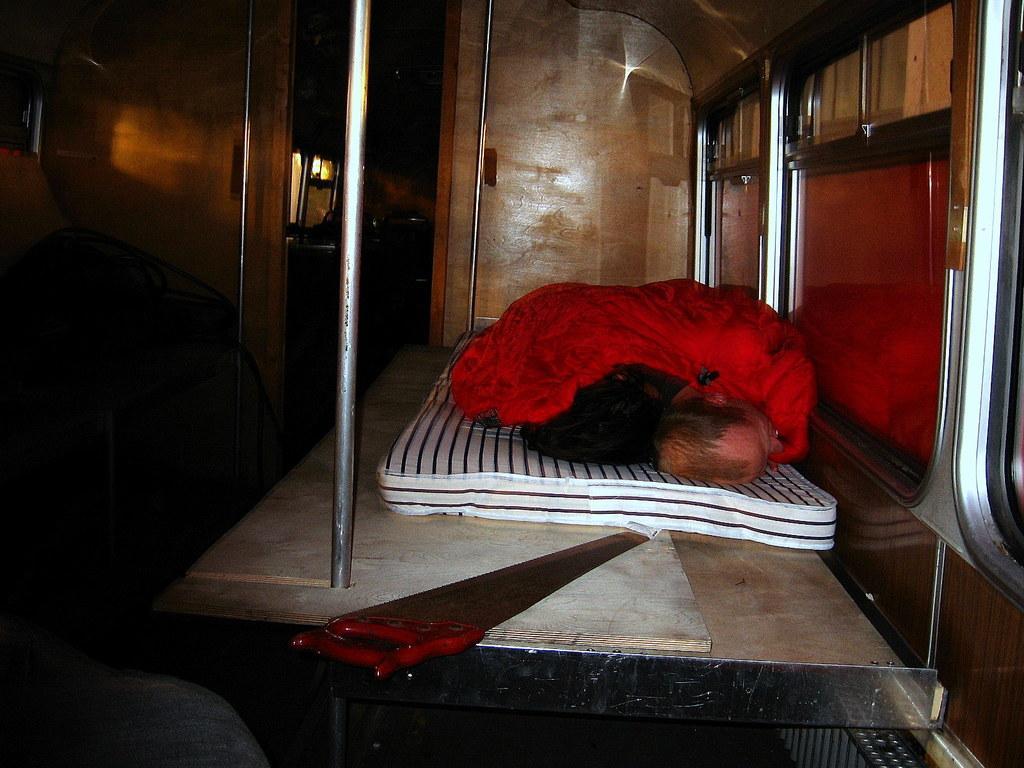In one or two sentences, can you explain what this image depicts? It seems to be an inside view of a vehicle. On the right side there are few windows. Beside the windows two persons are laying on a bed which is placed on a wooden plank and also there is a hand saw. On the left side there are few metal stands. In the background, I can see few objects in the dark. 